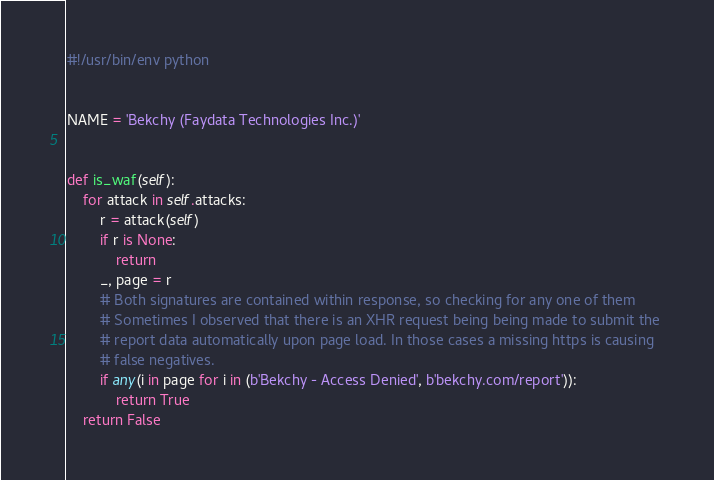<code> <loc_0><loc_0><loc_500><loc_500><_Python_>#!/usr/bin/env python


NAME = 'Bekchy (Faydata Technologies Inc.)'


def is_waf(self):
    for attack in self.attacks:
        r = attack(self)
        if r is None:
            return
        _, page = r
        # Both signatures are contained within response, so checking for any one of them
        # Sometimes I observed that there is an XHR request being being made to submit the 
        # report data automatically upon page load. In those cases a missing https is causing
        # false negatives.
        if any(i in page for i in (b'Bekchy - Access Denied', b'bekchy.com/report')):
            return True
    return False
</code> 